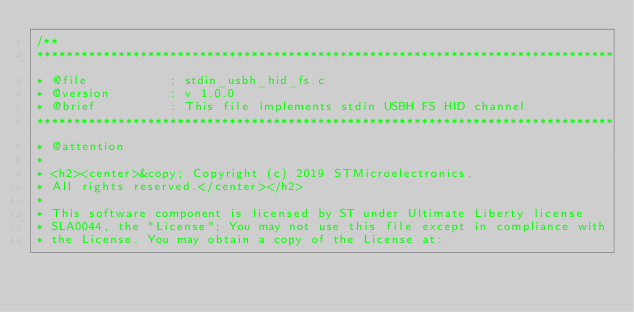<code> <loc_0><loc_0><loc_500><loc_500><_C_>/**
******************************************************************************
* @file           : stdin_usbh_hid_fs.c
* @version        : v 1.0.0
* @brief          : This file implements stdin USBH FS HID channel
******************************************************************************
* @attention
*
* <h2><center>&copy; Copyright (c) 2019 STMicroelectronics.
* All rights reserved.</center></h2>
*
* This software component is licensed by ST under Ultimate Liberty license
* SLA0044, the "License"; You may not use this file except in compliance with
* the License. You may obtain a copy of the License at:</code> 